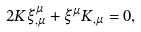Convert formula to latex. <formula><loc_0><loc_0><loc_500><loc_500>2 K \xi _ { , \mu } ^ { \mu } + \xi ^ { \mu } K _ { , \mu } = 0 ,</formula> 